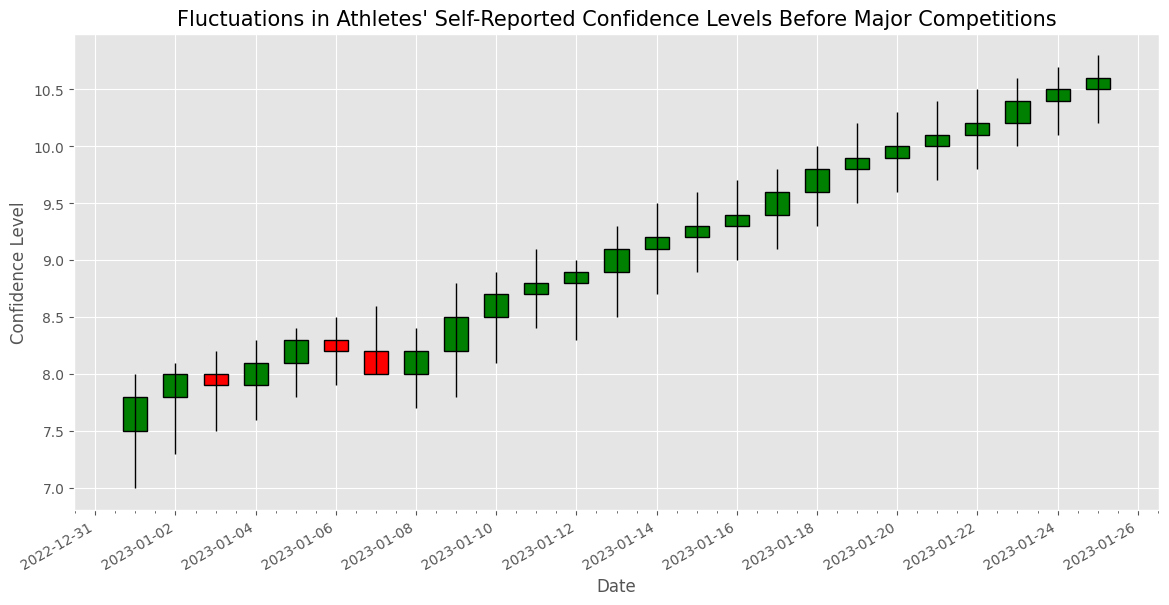What is the highest value of the self-reported confidence levels before the competition? The highest value is seen on January 25, reaching a high of 10.8. This can be directly deduced from the top of the highest candlestick.
Answer: 10.8 How does the close value on January 12 compare to January 13? Compare the close values of the two days. On January 12, the close value is 8.9, while on January 13, it is 9.1.
Answer: January 13 has a higher close value What is the trend in the closing values from January 10 to January 20? Observing the closing values from January 10 (8.7) to January 20 (10.0), we see a general upward trend.
Answer: Upward trend What is the average closing value from January 1 to January 5? To find the average, sum the closing values from January 1 (7.8), January 2 (8.0), January 3 (7.9), January 4 (8.1), and January 5 (8.3). Then divide by the number of days (5). (7.8 + 8.0 + 7.9 + 8.1 + 8.3) / 5 = 8.02
Answer: 8.02 Which day has the largest difference between the high and low values? Calculate the differences for each day and compare. The largest difference is on January 19 (10.2 - 9.5 = 0.7).
Answer: January 19 What is the color of the candlestick on January 8, and what does it signify? The candlestick on January 8 is green. This signifies that the closing value (8.2) is higher than the opening value (8.0).
Answer: Green, signifies a rise in value How many days have red candlesticks? Count the days where the closing value is less than the opening value. This occurs on January 3, January 7, and January 6.
Answer: 3 days What is the median closing value from January 10 to January 20? First, list the closing values in the range: 8.7, 8.8, 8.9, 9.1, 9.2, 9.3, 9.4, 9.6, 9.8, 9.9, 10.0. The median value, being the middle one in this ordered list, is 9.3.
Answer: 9.3 Which date has the lowest closing value, and what is it? The lowest closing value can be found on January 1, with a closing value of 7.8.
Answer: January 1, 7.8 How does the opening value on January 15 compare to January 16? On January 15, the opening value is 9.2, and on January 16, it is 9.3.
Answer: January 16 has a higher opening value 